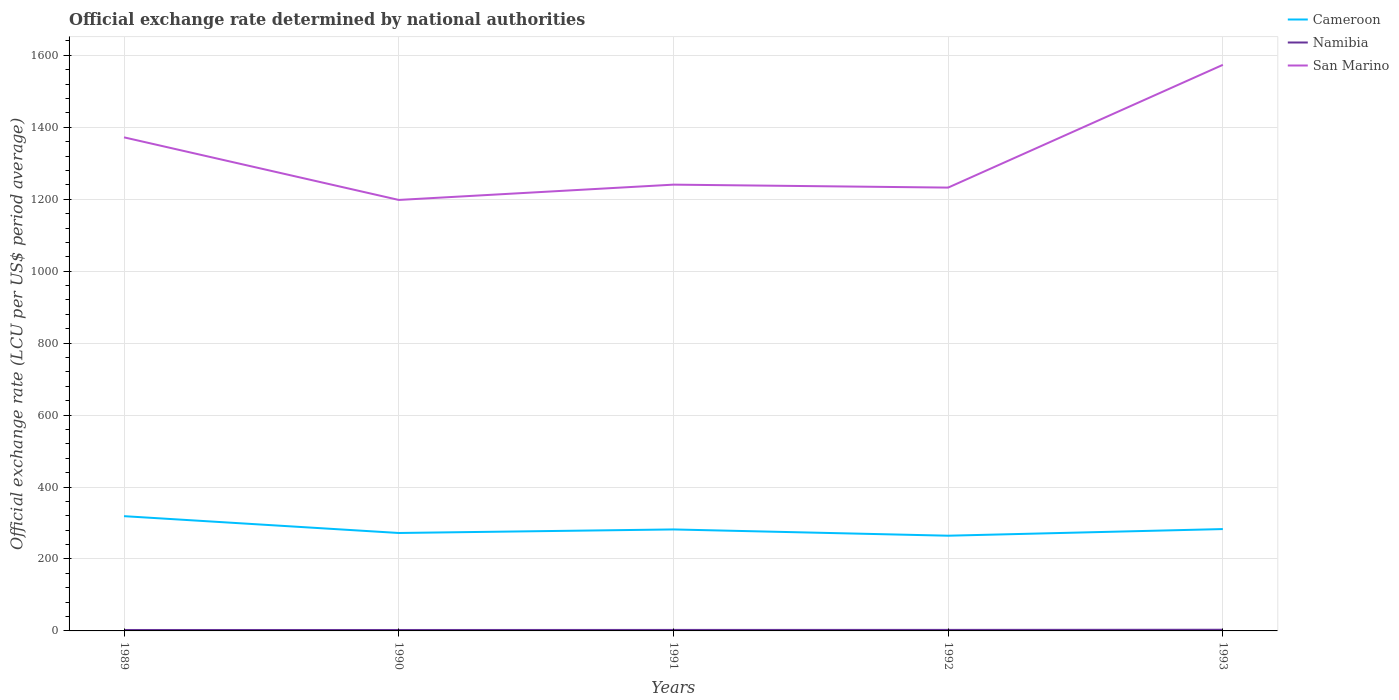How many different coloured lines are there?
Make the answer very short. 3. Across all years, what is the maximum official exchange rate in Namibia?
Give a very brief answer. 2.59. What is the total official exchange rate in San Marino in the graph?
Your answer should be compact. 131.48. What is the difference between the highest and the second highest official exchange rate in San Marino?
Make the answer very short. 375.56. How many lines are there?
Make the answer very short. 3. How many years are there in the graph?
Your answer should be compact. 5. Does the graph contain any zero values?
Your response must be concise. No. How are the legend labels stacked?
Your answer should be very brief. Vertical. What is the title of the graph?
Provide a short and direct response. Official exchange rate determined by national authorities. What is the label or title of the X-axis?
Offer a very short reply. Years. What is the label or title of the Y-axis?
Keep it short and to the point. Official exchange rate (LCU per US$ period average). What is the Official exchange rate (LCU per US$ period average) in Cameroon in 1989?
Provide a succinct answer. 319.01. What is the Official exchange rate (LCU per US$ period average) of Namibia in 1989?
Keep it short and to the point. 2.62. What is the Official exchange rate (LCU per US$ period average) in San Marino in 1989?
Make the answer very short. 1372.09. What is the Official exchange rate (LCU per US$ period average) in Cameroon in 1990?
Provide a short and direct response. 272.26. What is the Official exchange rate (LCU per US$ period average) in Namibia in 1990?
Your answer should be very brief. 2.59. What is the Official exchange rate (LCU per US$ period average) of San Marino in 1990?
Provide a short and direct response. 1198.1. What is the Official exchange rate (LCU per US$ period average) in Cameroon in 1991?
Provide a succinct answer. 282.11. What is the Official exchange rate (LCU per US$ period average) of Namibia in 1991?
Provide a succinct answer. 2.76. What is the Official exchange rate (LCU per US$ period average) in San Marino in 1991?
Provide a succinct answer. 1240.61. What is the Official exchange rate (LCU per US$ period average) of Cameroon in 1992?
Provide a succinct answer. 264.69. What is the Official exchange rate (LCU per US$ period average) of Namibia in 1992?
Keep it short and to the point. 2.85. What is the Official exchange rate (LCU per US$ period average) in San Marino in 1992?
Provide a short and direct response. 1232.41. What is the Official exchange rate (LCU per US$ period average) in Cameroon in 1993?
Make the answer very short. 283.16. What is the Official exchange rate (LCU per US$ period average) of Namibia in 1993?
Make the answer very short. 3.27. What is the Official exchange rate (LCU per US$ period average) in San Marino in 1993?
Offer a terse response. 1573.67. Across all years, what is the maximum Official exchange rate (LCU per US$ period average) in Cameroon?
Give a very brief answer. 319.01. Across all years, what is the maximum Official exchange rate (LCU per US$ period average) in Namibia?
Provide a succinct answer. 3.27. Across all years, what is the maximum Official exchange rate (LCU per US$ period average) in San Marino?
Your answer should be very brief. 1573.67. Across all years, what is the minimum Official exchange rate (LCU per US$ period average) in Cameroon?
Make the answer very short. 264.69. Across all years, what is the minimum Official exchange rate (LCU per US$ period average) of Namibia?
Your response must be concise. 2.59. Across all years, what is the minimum Official exchange rate (LCU per US$ period average) in San Marino?
Offer a terse response. 1198.1. What is the total Official exchange rate (LCU per US$ period average) in Cameroon in the graph?
Offer a terse response. 1421.23. What is the total Official exchange rate (LCU per US$ period average) in Namibia in the graph?
Offer a very short reply. 14.09. What is the total Official exchange rate (LCU per US$ period average) of San Marino in the graph?
Give a very brief answer. 6616.88. What is the difference between the Official exchange rate (LCU per US$ period average) in Cameroon in 1989 and that in 1990?
Offer a terse response. 46.74. What is the difference between the Official exchange rate (LCU per US$ period average) of Namibia in 1989 and that in 1990?
Provide a succinct answer. 0.04. What is the difference between the Official exchange rate (LCU per US$ period average) of San Marino in 1989 and that in 1990?
Your answer should be compact. 173.99. What is the difference between the Official exchange rate (LCU per US$ period average) of Cameroon in 1989 and that in 1991?
Your response must be concise. 36.9. What is the difference between the Official exchange rate (LCU per US$ period average) of Namibia in 1989 and that in 1991?
Offer a terse response. -0.14. What is the difference between the Official exchange rate (LCU per US$ period average) in San Marino in 1989 and that in 1991?
Your response must be concise. 131.48. What is the difference between the Official exchange rate (LCU per US$ period average) of Cameroon in 1989 and that in 1992?
Offer a terse response. 54.32. What is the difference between the Official exchange rate (LCU per US$ period average) of Namibia in 1989 and that in 1992?
Provide a succinct answer. -0.23. What is the difference between the Official exchange rate (LCU per US$ period average) in San Marino in 1989 and that in 1992?
Give a very brief answer. 139.69. What is the difference between the Official exchange rate (LCU per US$ period average) in Cameroon in 1989 and that in 1993?
Offer a terse response. 35.85. What is the difference between the Official exchange rate (LCU per US$ period average) of Namibia in 1989 and that in 1993?
Your response must be concise. -0.65. What is the difference between the Official exchange rate (LCU per US$ period average) of San Marino in 1989 and that in 1993?
Ensure brevity in your answer.  -201.57. What is the difference between the Official exchange rate (LCU per US$ period average) of Cameroon in 1990 and that in 1991?
Your answer should be compact. -9.84. What is the difference between the Official exchange rate (LCU per US$ period average) in Namibia in 1990 and that in 1991?
Ensure brevity in your answer.  -0.17. What is the difference between the Official exchange rate (LCU per US$ period average) in San Marino in 1990 and that in 1991?
Offer a terse response. -42.51. What is the difference between the Official exchange rate (LCU per US$ period average) in Cameroon in 1990 and that in 1992?
Offer a terse response. 7.57. What is the difference between the Official exchange rate (LCU per US$ period average) in Namibia in 1990 and that in 1992?
Give a very brief answer. -0.26. What is the difference between the Official exchange rate (LCU per US$ period average) of San Marino in 1990 and that in 1992?
Make the answer very short. -34.3. What is the difference between the Official exchange rate (LCU per US$ period average) in Cameroon in 1990 and that in 1993?
Give a very brief answer. -10.9. What is the difference between the Official exchange rate (LCU per US$ period average) of Namibia in 1990 and that in 1993?
Give a very brief answer. -0.68. What is the difference between the Official exchange rate (LCU per US$ period average) of San Marino in 1990 and that in 1993?
Ensure brevity in your answer.  -375.56. What is the difference between the Official exchange rate (LCU per US$ period average) in Cameroon in 1991 and that in 1992?
Offer a terse response. 17.42. What is the difference between the Official exchange rate (LCU per US$ period average) of Namibia in 1991 and that in 1992?
Your answer should be compact. -0.09. What is the difference between the Official exchange rate (LCU per US$ period average) of San Marino in 1991 and that in 1992?
Give a very brief answer. 8.21. What is the difference between the Official exchange rate (LCU per US$ period average) of Cameroon in 1991 and that in 1993?
Provide a succinct answer. -1.06. What is the difference between the Official exchange rate (LCU per US$ period average) in Namibia in 1991 and that in 1993?
Give a very brief answer. -0.51. What is the difference between the Official exchange rate (LCU per US$ period average) in San Marino in 1991 and that in 1993?
Give a very brief answer. -333.05. What is the difference between the Official exchange rate (LCU per US$ period average) in Cameroon in 1992 and that in 1993?
Keep it short and to the point. -18.47. What is the difference between the Official exchange rate (LCU per US$ period average) in Namibia in 1992 and that in 1993?
Your response must be concise. -0.42. What is the difference between the Official exchange rate (LCU per US$ period average) of San Marino in 1992 and that in 1993?
Ensure brevity in your answer.  -341.26. What is the difference between the Official exchange rate (LCU per US$ period average) in Cameroon in 1989 and the Official exchange rate (LCU per US$ period average) in Namibia in 1990?
Ensure brevity in your answer.  316.42. What is the difference between the Official exchange rate (LCU per US$ period average) in Cameroon in 1989 and the Official exchange rate (LCU per US$ period average) in San Marino in 1990?
Provide a succinct answer. -879.09. What is the difference between the Official exchange rate (LCU per US$ period average) in Namibia in 1989 and the Official exchange rate (LCU per US$ period average) in San Marino in 1990?
Your response must be concise. -1195.48. What is the difference between the Official exchange rate (LCU per US$ period average) of Cameroon in 1989 and the Official exchange rate (LCU per US$ period average) of Namibia in 1991?
Your answer should be compact. 316.25. What is the difference between the Official exchange rate (LCU per US$ period average) in Cameroon in 1989 and the Official exchange rate (LCU per US$ period average) in San Marino in 1991?
Your response must be concise. -921.61. What is the difference between the Official exchange rate (LCU per US$ period average) of Namibia in 1989 and the Official exchange rate (LCU per US$ period average) of San Marino in 1991?
Provide a short and direct response. -1237.99. What is the difference between the Official exchange rate (LCU per US$ period average) of Cameroon in 1989 and the Official exchange rate (LCU per US$ period average) of Namibia in 1992?
Offer a terse response. 316.16. What is the difference between the Official exchange rate (LCU per US$ period average) of Cameroon in 1989 and the Official exchange rate (LCU per US$ period average) of San Marino in 1992?
Give a very brief answer. -913.4. What is the difference between the Official exchange rate (LCU per US$ period average) of Namibia in 1989 and the Official exchange rate (LCU per US$ period average) of San Marino in 1992?
Make the answer very short. -1229.78. What is the difference between the Official exchange rate (LCU per US$ period average) of Cameroon in 1989 and the Official exchange rate (LCU per US$ period average) of Namibia in 1993?
Give a very brief answer. 315.74. What is the difference between the Official exchange rate (LCU per US$ period average) of Cameroon in 1989 and the Official exchange rate (LCU per US$ period average) of San Marino in 1993?
Offer a very short reply. -1254.66. What is the difference between the Official exchange rate (LCU per US$ period average) of Namibia in 1989 and the Official exchange rate (LCU per US$ period average) of San Marino in 1993?
Make the answer very short. -1571.04. What is the difference between the Official exchange rate (LCU per US$ period average) in Cameroon in 1990 and the Official exchange rate (LCU per US$ period average) in Namibia in 1991?
Keep it short and to the point. 269.5. What is the difference between the Official exchange rate (LCU per US$ period average) in Cameroon in 1990 and the Official exchange rate (LCU per US$ period average) in San Marino in 1991?
Ensure brevity in your answer.  -968.35. What is the difference between the Official exchange rate (LCU per US$ period average) in Namibia in 1990 and the Official exchange rate (LCU per US$ period average) in San Marino in 1991?
Provide a short and direct response. -1238.03. What is the difference between the Official exchange rate (LCU per US$ period average) of Cameroon in 1990 and the Official exchange rate (LCU per US$ period average) of Namibia in 1992?
Provide a short and direct response. 269.41. What is the difference between the Official exchange rate (LCU per US$ period average) of Cameroon in 1990 and the Official exchange rate (LCU per US$ period average) of San Marino in 1992?
Provide a short and direct response. -960.14. What is the difference between the Official exchange rate (LCU per US$ period average) in Namibia in 1990 and the Official exchange rate (LCU per US$ period average) in San Marino in 1992?
Make the answer very short. -1229.82. What is the difference between the Official exchange rate (LCU per US$ period average) in Cameroon in 1990 and the Official exchange rate (LCU per US$ period average) in Namibia in 1993?
Provide a succinct answer. 269. What is the difference between the Official exchange rate (LCU per US$ period average) in Cameroon in 1990 and the Official exchange rate (LCU per US$ period average) in San Marino in 1993?
Give a very brief answer. -1301.4. What is the difference between the Official exchange rate (LCU per US$ period average) of Namibia in 1990 and the Official exchange rate (LCU per US$ period average) of San Marino in 1993?
Ensure brevity in your answer.  -1571.08. What is the difference between the Official exchange rate (LCU per US$ period average) of Cameroon in 1991 and the Official exchange rate (LCU per US$ period average) of Namibia in 1992?
Keep it short and to the point. 279.25. What is the difference between the Official exchange rate (LCU per US$ period average) of Cameroon in 1991 and the Official exchange rate (LCU per US$ period average) of San Marino in 1992?
Ensure brevity in your answer.  -950.3. What is the difference between the Official exchange rate (LCU per US$ period average) in Namibia in 1991 and the Official exchange rate (LCU per US$ period average) in San Marino in 1992?
Give a very brief answer. -1229.64. What is the difference between the Official exchange rate (LCU per US$ period average) in Cameroon in 1991 and the Official exchange rate (LCU per US$ period average) in Namibia in 1993?
Offer a very short reply. 278.84. What is the difference between the Official exchange rate (LCU per US$ period average) of Cameroon in 1991 and the Official exchange rate (LCU per US$ period average) of San Marino in 1993?
Give a very brief answer. -1291.56. What is the difference between the Official exchange rate (LCU per US$ period average) of Namibia in 1991 and the Official exchange rate (LCU per US$ period average) of San Marino in 1993?
Give a very brief answer. -1570.9. What is the difference between the Official exchange rate (LCU per US$ period average) in Cameroon in 1992 and the Official exchange rate (LCU per US$ period average) in Namibia in 1993?
Make the answer very short. 261.42. What is the difference between the Official exchange rate (LCU per US$ period average) of Cameroon in 1992 and the Official exchange rate (LCU per US$ period average) of San Marino in 1993?
Offer a very short reply. -1308.97. What is the difference between the Official exchange rate (LCU per US$ period average) in Namibia in 1992 and the Official exchange rate (LCU per US$ period average) in San Marino in 1993?
Your answer should be very brief. -1570.81. What is the average Official exchange rate (LCU per US$ period average) of Cameroon per year?
Offer a very short reply. 284.25. What is the average Official exchange rate (LCU per US$ period average) in Namibia per year?
Your answer should be very brief. 2.82. What is the average Official exchange rate (LCU per US$ period average) of San Marino per year?
Your response must be concise. 1323.38. In the year 1989, what is the difference between the Official exchange rate (LCU per US$ period average) in Cameroon and Official exchange rate (LCU per US$ period average) in Namibia?
Your answer should be compact. 316.39. In the year 1989, what is the difference between the Official exchange rate (LCU per US$ period average) in Cameroon and Official exchange rate (LCU per US$ period average) in San Marino?
Provide a succinct answer. -1053.09. In the year 1989, what is the difference between the Official exchange rate (LCU per US$ period average) in Namibia and Official exchange rate (LCU per US$ period average) in San Marino?
Offer a very short reply. -1369.47. In the year 1990, what is the difference between the Official exchange rate (LCU per US$ period average) of Cameroon and Official exchange rate (LCU per US$ period average) of Namibia?
Offer a very short reply. 269.68. In the year 1990, what is the difference between the Official exchange rate (LCU per US$ period average) in Cameroon and Official exchange rate (LCU per US$ period average) in San Marino?
Provide a succinct answer. -925.84. In the year 1990, what is the difference between the Official exchange rate (LCU per US$ period average) of Namibia and Official exchange rate (LCU per US$ period average) of San Marino?
Keep it short and to the point. -1195.51. In the year 1991, what is the difference between the Official exchange rate (LCU per US$ period average) of Cameroon and Official exchange rate (LCU per US$ period average) of Namibia?
Offer a very short reply. 279.35. In the year 1991, what is the difference between the Official exchange rate (LCU per US$ period average) of Cameroon and Official exchange rate (LCU per US$ period average) of San Marino?
Offer a terse response. -958.51. In the year 1991, what is the difference between the Official exchange rate (LCU per US$ period average) in Namibia and Official exchange rate (LCU per US$ period average) in San Marino?
Ensure brevity in your answer.  -1237.85. In the year 1992, what is the difference between the Official exchange rate (LCU per US$ period average) in Cameroon and Official exchange rate (LCU per US$ period average) in Namibia?
Make the answer very short. 261.84. In the year 1992, what is the difference between the Official exchange rate (LCU per US$ period average) of Cameroon and Official exchange rate (LCU per US$ period average) of San Marino?
Offer a terse response. -967.71. In the year 1992, what is the difference between the Official exchange rate (LCU per US$ period average) of Namibia and Official exchange rate (LCU per US$ period average) of San Marino?
Provide a short and direct response. -1229.55. In the year 1993, what is the difference between the Official exchange rate (LCU per US$ period average) of Cameroon and Official exchange rate (LCU per US$ period average) of Namibia?
Your response must be concise. 279.89. In the year 1993, what is the difference between the Official exchange rate (LCU per US$ period average) of Cameroon and Official exchange rate (LCU per US$ period average) of San Marino?
Offer a very short reply. -1290.5. In the year 1993, what is the difference between the Official exchange rate (LCU per US$ period average) of Namibia and Official exchange rate (LCU per US$ period average) of San Marino?
Make the answer very short. -1570.4. What is the ratio of the Official exchange rate (LCU per US$ period average) of Cameroon in 1989 to that in 1990?
Your response must be concise. 1.17. What is the ratio of the Official exchange rate (LCU per US$ period average) in Namibia in 1989 to that in 1990?
Keep it short and to the point. 1.01. What is the ratio of the Official exchange rate (LCU per US$ period average) in San Marino in 1989 to that in 1990?
Your answer should be compact. 1.15. What is the ratio of the Official exchange rate (LCU per US$ period average) in Cameroon in 1989 to that in 1991?
Offer a very short reply. 1.13. What is the ratio of the Official exchange rate (LCU per US$ period average) of Namibia in 1989 to that in 1991?
Make the answer very short. 0.95. What is the ratio of the Official exchange rate (LCU per US$ period average) in San Marino in 1989 to that in 1991?
Make the answer very short. 1.11. What is the ratio of the Official exchange rate (LCU per US$ period average) of Cameroon in 1989 to that in 1992?
Your response must be concise. 1.21. What is the ratio of the Official exchange rate (LCU per US$ period average) in Namibia in 1989 to that in 1992?
Keep it short and to the point. 0.92. What is the ratio of the Official exchange rate (LCU per US$ period average) in San Marino in 1989 to that in 1992?
Your answer should be compact. 1.11. What is the ratio of the Official exchange rate (LCU per US$ period average) of Cameroon in 1989 to that in 1993?
Make the answer very short. 1.13. What is the ratio of the Official exchange rate (LCU per US$ period average) of Namibia in 1989 to that in 1993?
Provide a short and direct response. 0.8. What is the ratio of the Official exchange rate (LCU per US$ period average) in San Marino in 1989 to that in 1993?
Offer a very short reply. 0.87. What is the ratio of the Official exchange rate (LCU per US$ period average) of Cameroon in 1990 to that in 1991?
Your response must be concise. 0.97. What is the ratio of the Official exchange rate (LCU per US$ period average) in Namibia in 1990 to that in 1991?
Give a very brief answer. 0.94. What is the ratio of the Official exchange rate (LCU per US$ period average) in San Marino in 1990 to that in 1991?
Offer a very short reply. 0.97. What is the ratio of the Official exchange rate (LCU per US$ period average) in Cameroon in 1990 to that in 1992?
Offer a terse response. 1.03. What is the ratio of the Official exchange rate (LCU per US$ period average) of Namibia in 1990 to that in 1992?
Offer a terse response. 0.91. What is the ratio of the Official exchange rate (LCU per US$ period average) in San Marino in 1990 to that in 1992?
Offer a terse response. 0.97. What is the ratio of the Official exchange rate (LCU per US$ period average) in Cameroon in 1990 to that in 1993?
Offer a very short reply. 0.96. What is the ratio of the Official exchange rate (LCU per US$ period average) of Namibia in 1990 to that in 1993?
Offer a terse response. 0.79. What is the ratio of the Official exchange rate (LCU per US$ period average) of San Marino in 1990 to that in 1993?
Give a very brief answer. 0.76. What is the ratio of the Official exchange rate (LCU per US$ period average) in Cameroon in 1991 to that in 1992?
Your answer should be very brief. 1.07. What is the ratio of the Official exchange rate (LCU per US$ period average) in Namibia in 1991 to that in 1992?
Your answer should be compact. 0.97. What is the ratio of the Official exchange rate (LCU per US$ period average) of San Marino in 1991 to that in 1992?
Provide a succinct answer. 1.01. What is the ratio of the Official exchange rate (LCU per US$ period average) in Namibia in 1991 to that in 1993?
Provide a short and direct response. 0.84. What is the ratio of the Official exchange rate (LCU per US$ period average) of San Marino in 1991 to that in 1993?
Make the answer very short. 0.79. What is the ratio of the Official exchange rate (LCU per US$ period average) in Cameroon in 1992 to that in 1993?
Offer a very short reply. 0.93. What is the ratio of the Official exchange rate (LCU per US$ period average) of Namibia in 1992 to that in 1993?
Your answer should be very brief. 0.87. What is the ratio of the Official exchange rate (LCU per US$ period average) of San Marino in 1992 to that in 1993?
Offer a very short reply. 0.78. What is the difference between the highest and the second highest Official exchange rate (LCU per US$ period average) in Cameroon?
Make the answer very short. 35.85. What is the difference between the highest and the second highest Official exchange rate (LCU per US$ period average) of Namibia?
Ensure brevity in your answer.  0.42. What is the difference between the highest and the second highest Official exchange rate (LCU per US$ period average) in San Marino?
Make the answer very short. 201.57. What is the difference between the highest and the lowest Official exchange rate (LCU per US$ period average) of Cameroon?
Ensure brevity in your answer.  54.32. What is the difference between the highest and the lowest Official exchange rate (LCU per US$ period average) of Namibia?
Your answer should be very brief. 0.68. What is the difference between the highest and the lowest Official exchange rate (LCU per US$ period average) of San Marino?
Offer a terse response. 375.56. 